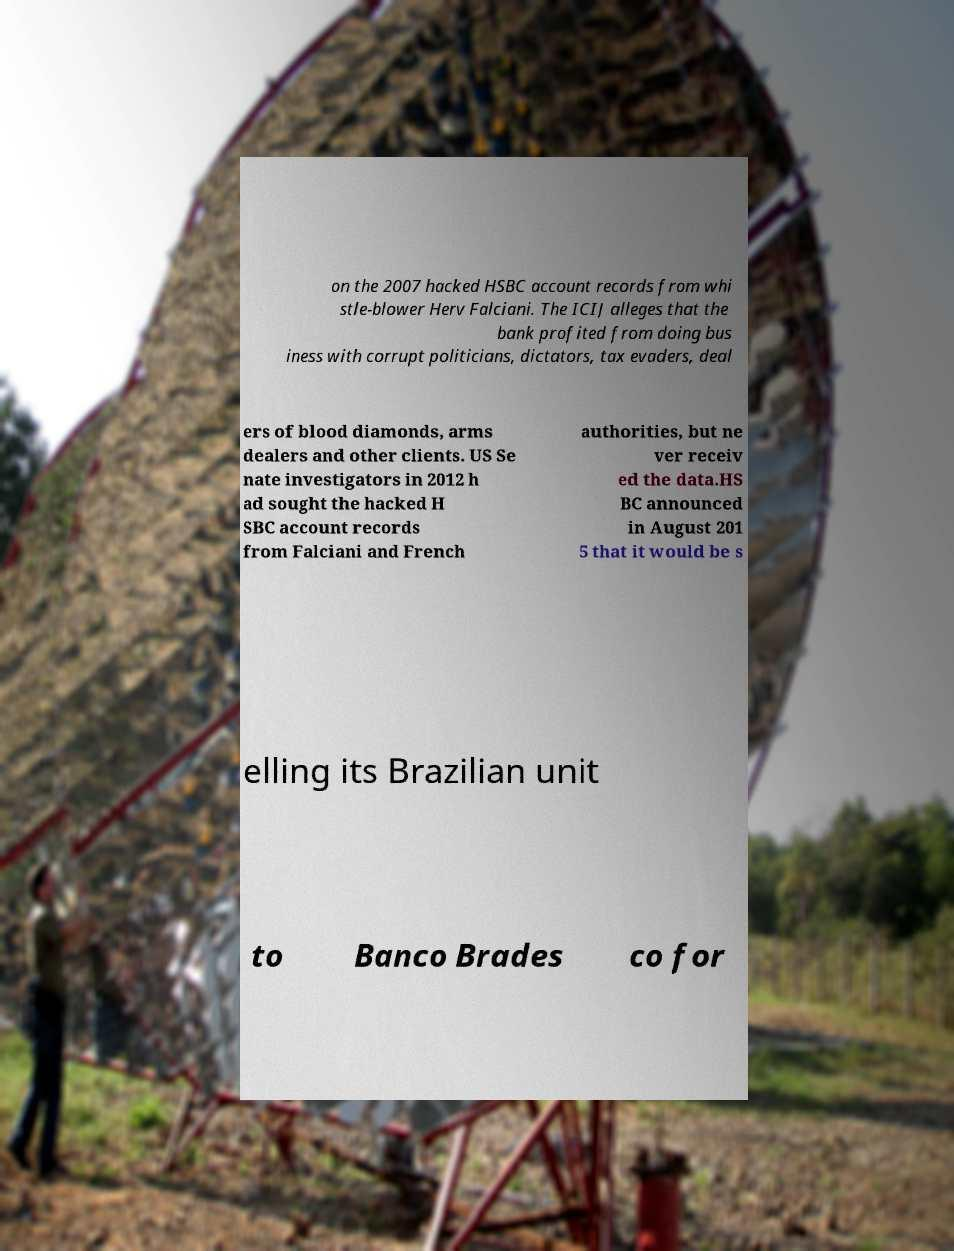Please identify and transcribe the text found in this image. on the 2007 hacked HSBC account records from whi stle-blower Herv Falciani. The ICIJ alleges that the bank profited from doing bus iness with corrupt politicians, dictators, tax evaders, deal ers of blood diamonds, arms dealers and other clients. US Se nate investigators in 2012 h ad sought the hacked H SBC account records from Falciani and French authorities, but ne ver receiv ed the data.HS BC announced in August 201 5 that it would be s elling its Brazilian unit to Banco Brades co for 